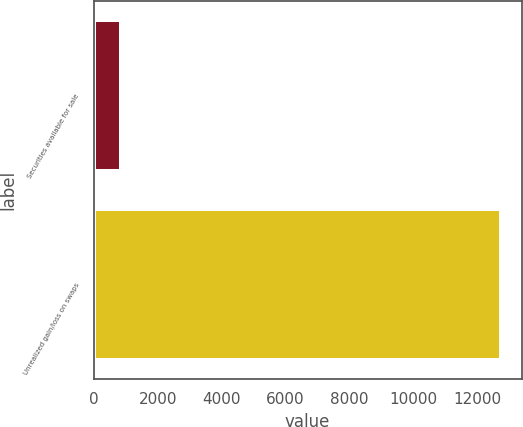<chart> <loc_0><loc_0><loc_500><loc_500><bar_chart><fcel>Securities available for sale<fcel>Unrealized gain/loss on swaps<nl><fcel>863<fcel>12740<nl></chart> 